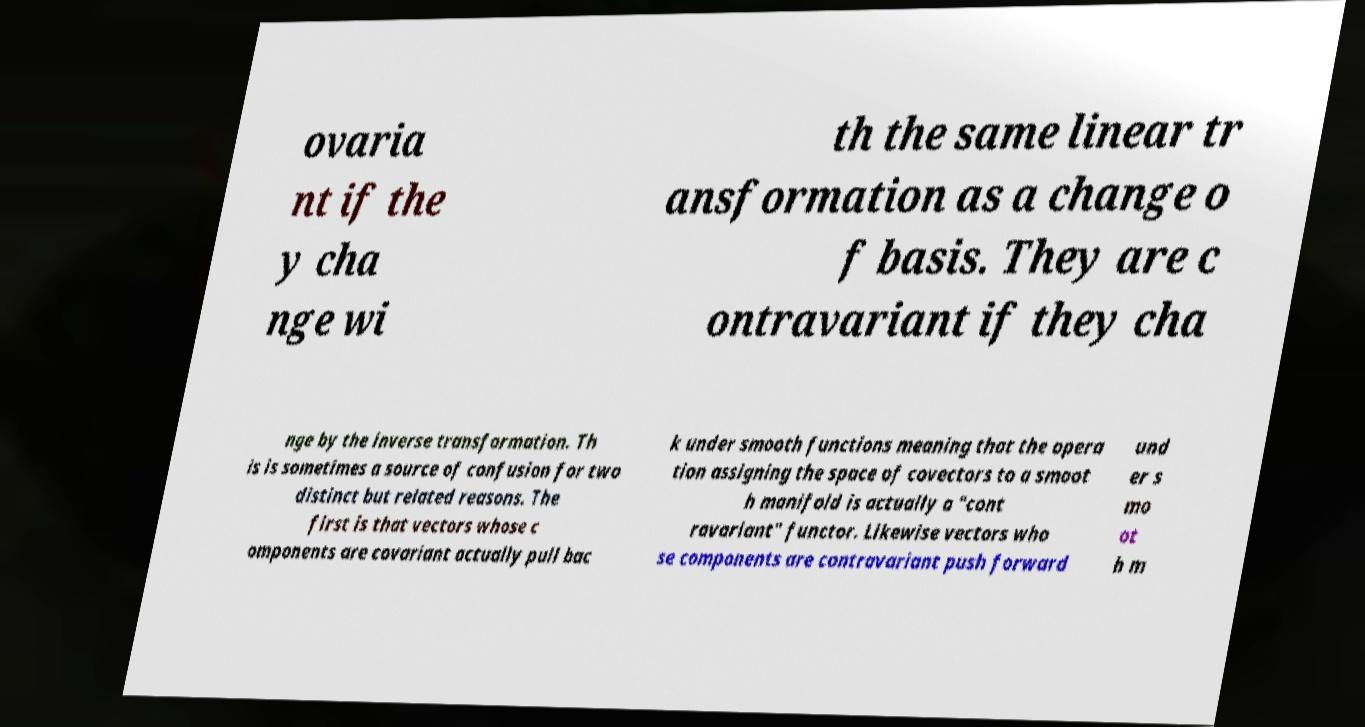Please read and relay the text visible in this image. What does it say? ovaria nt if the y cha nge wi th the same linear tr ansformation as a change o f basis. They are c ontravariant if they cha nge by the inverse transformation. Th is is sometimes a source of confusion for two distinct but related reasons. The first is that vectors whose c omponents are covariant actually pull bac k under smooth functions meaning that the opera tion assigning the space of covectors to a smoot h manifold is actually a "cont ravariant" functor. Likewise vectors who se components are contravariant push forward und er s mo ot h m 